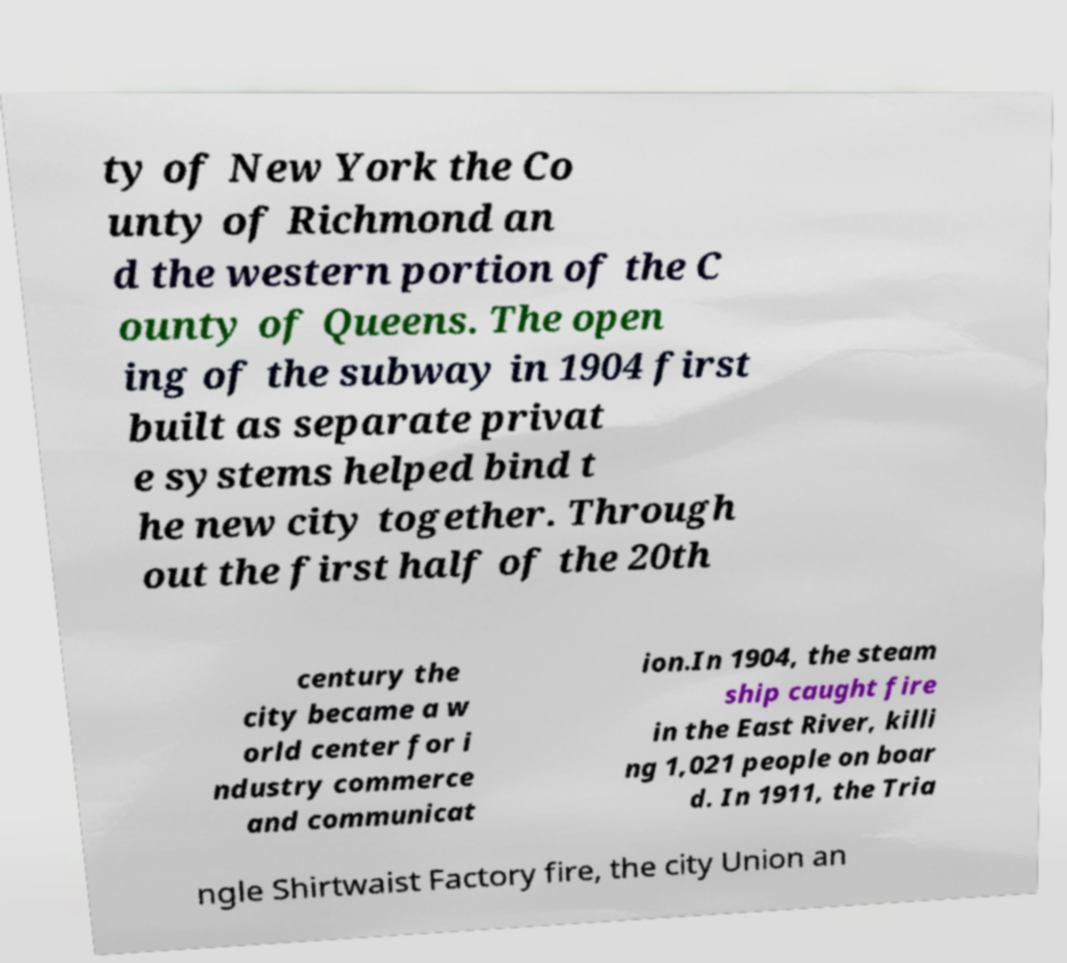What messages or text are displayed in this image? I need them in a readable, typed format. ty of New York the Co unty of Richmond an d the western portion of the C ounty of Queens. The open ing of the subway in 1904 first built as separate privat e systems helped bind t he new city together. Through out the first half of the 20th century the city became a w orld center for i ndustry commerce and communicat ion.In 1904, the steam ship caught fire in the East River, killi ng 1,021 people on boar d. In 1911, the Tria ngle Shirtwaist Factory fire, the city Union an 